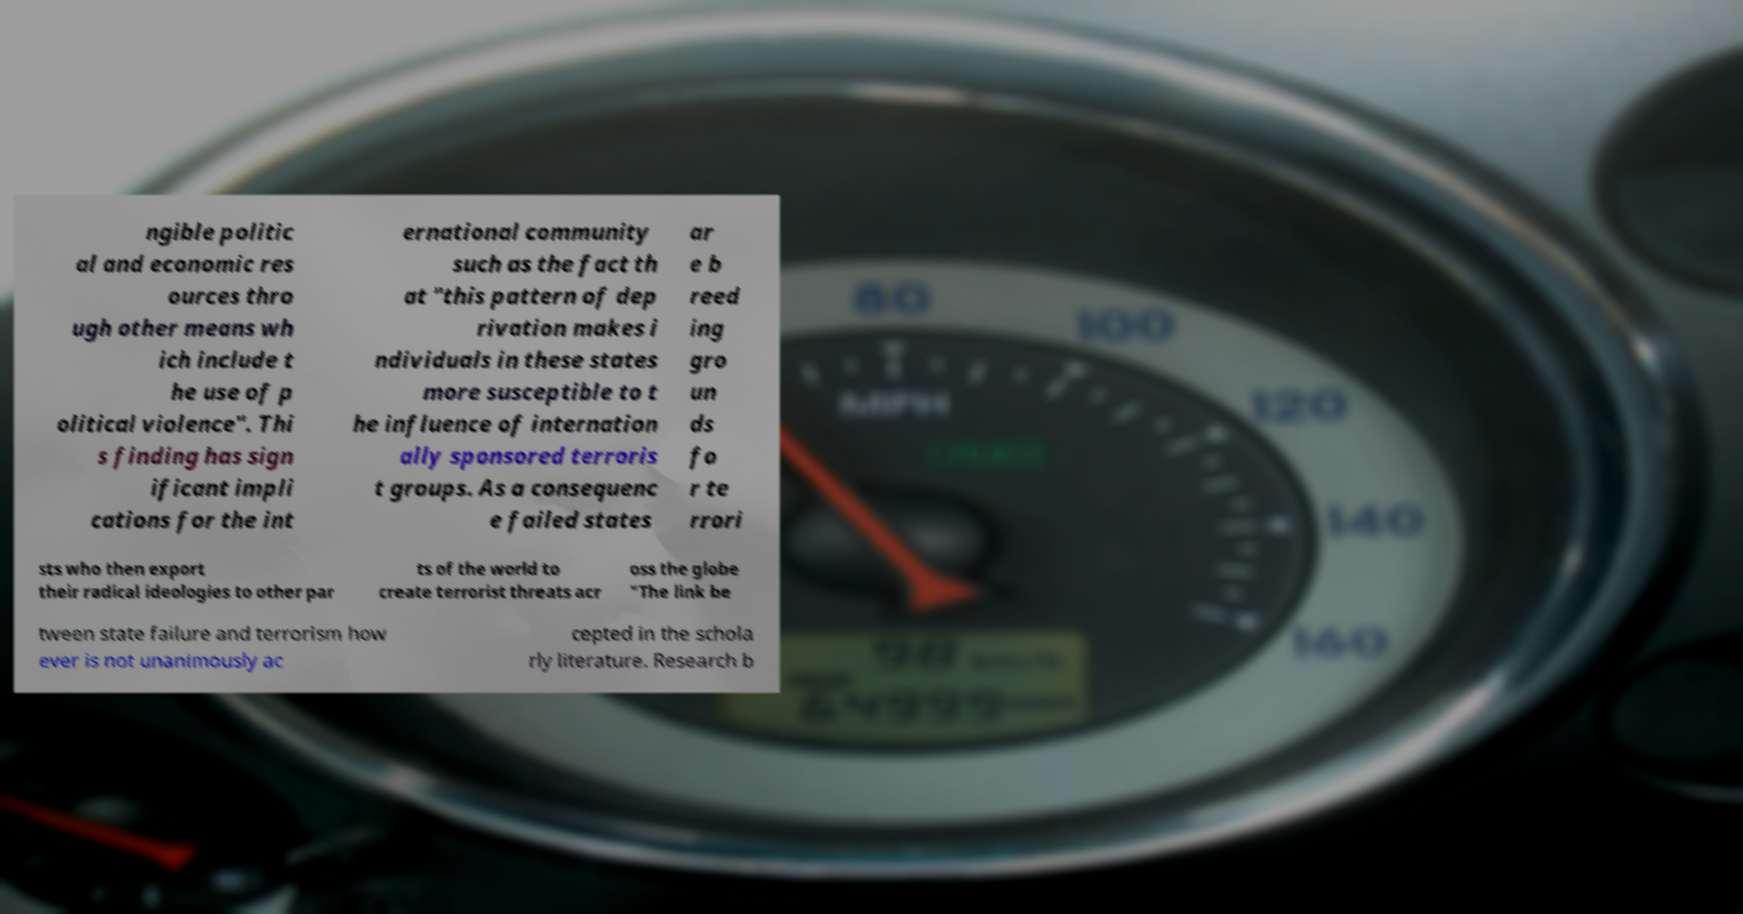There's text embedded in this image that I need extracted. Can you transcribe it verbatim? ngible politic al and economic res ources thro ugh other means wh ich include t he use of p olitical violence". Thi s finding has sign ificant impli cations for the int ernational community such as the fact th at "this pattern of dep rivation makes i ndividuals in these states more susceptible to t he influence of internation ally sponsored terroris t groups. As a consequenc e failed states ar e b reed ing gro un ds fo r te rrori sts who then export their radical ideologies to other par ts of the world to create terrorist threats acr oss the globe "The link be tween state failure and terrorism how ever is not unanimously ac cepted in the schola rly literature. Research b 